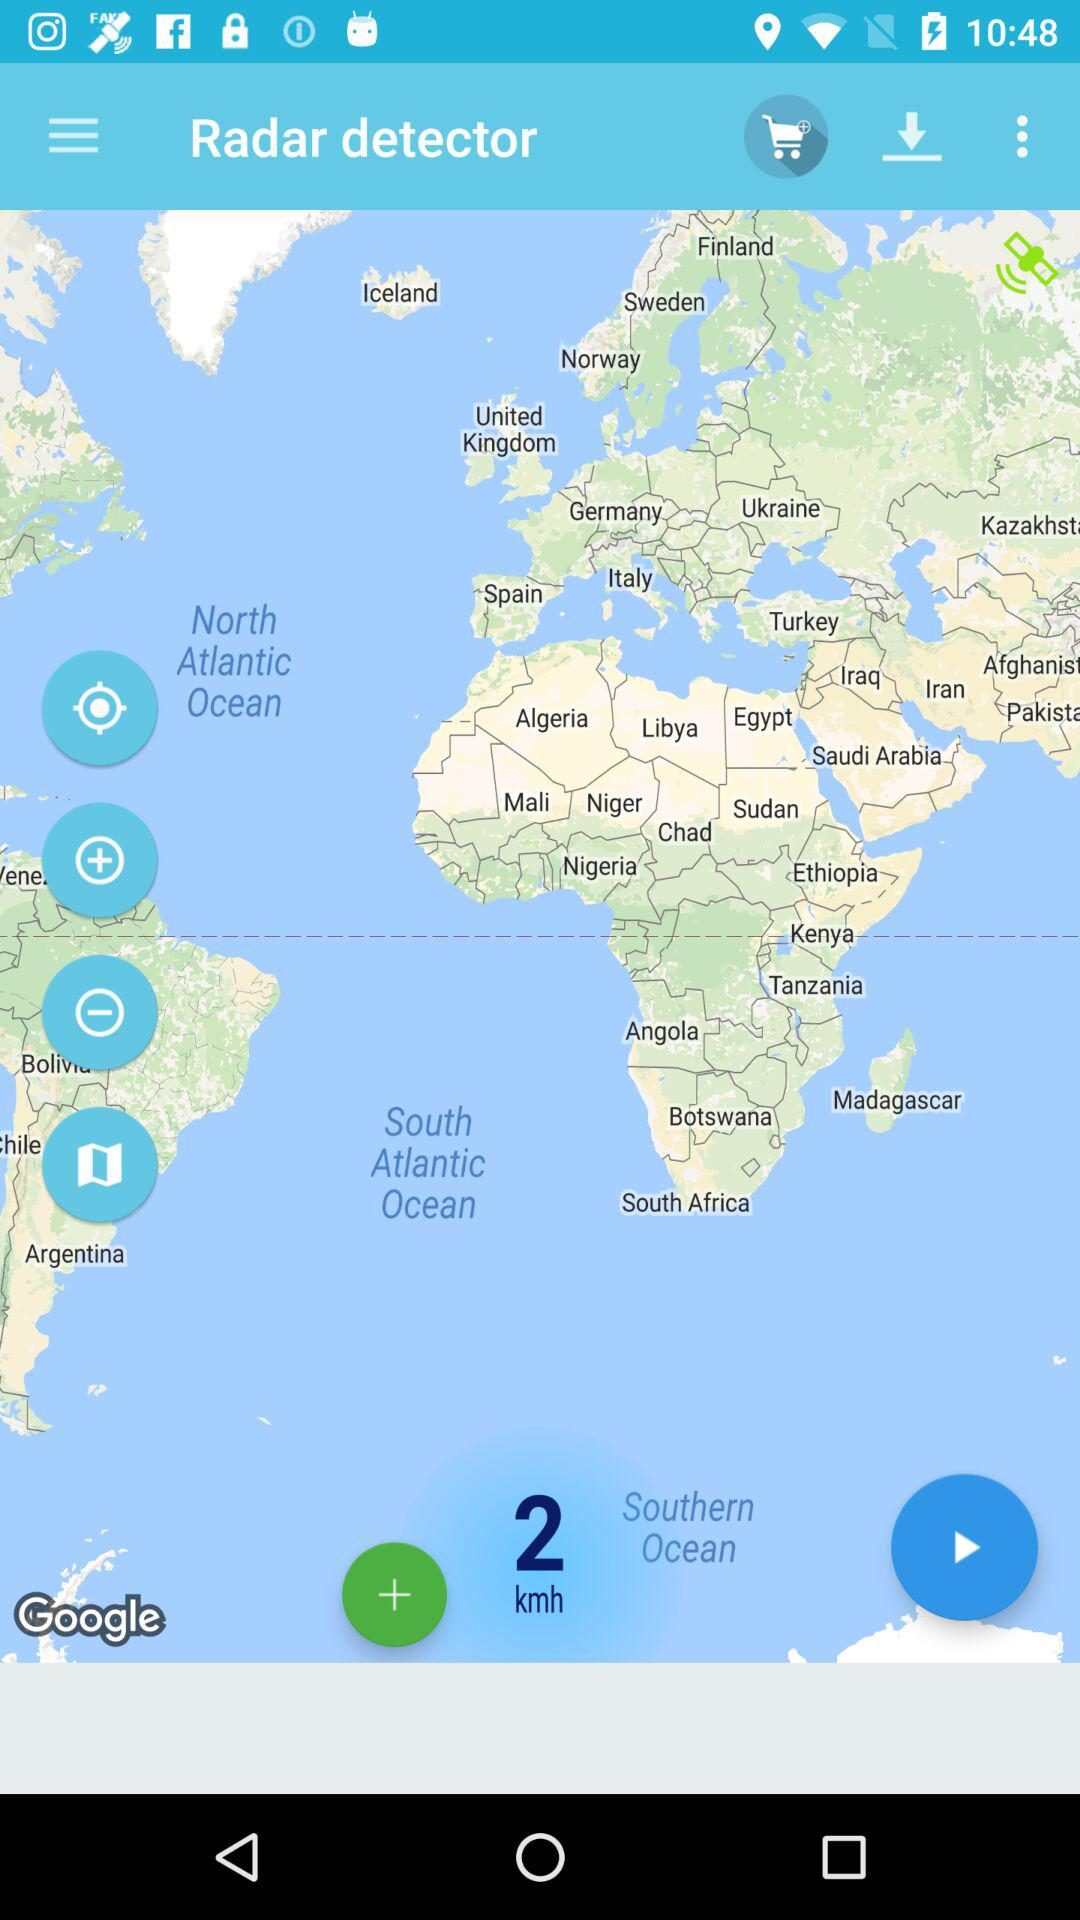What is the name of the application? The name of the application is "Radar detector". 